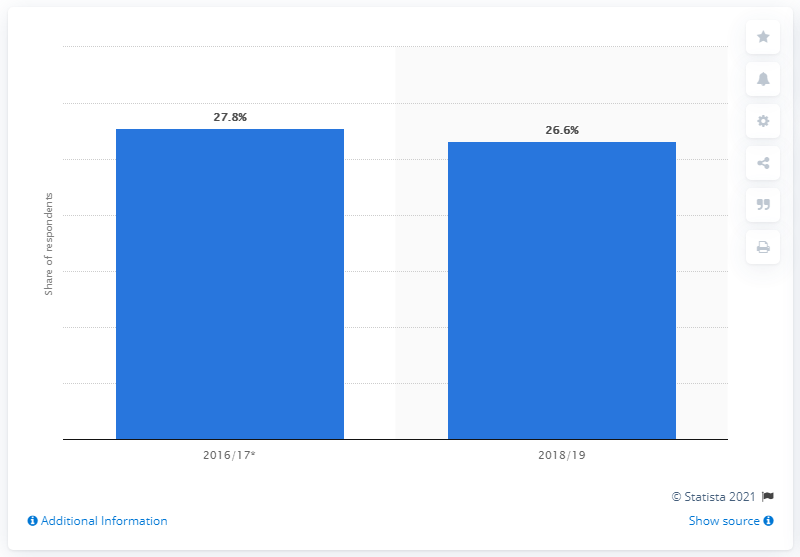List a handful of essential elements in this visual. According to the survey, 26.6% of respondents in Ecuador reported having been asked or required to pay a bribe in various interactions with public and private authorities. 